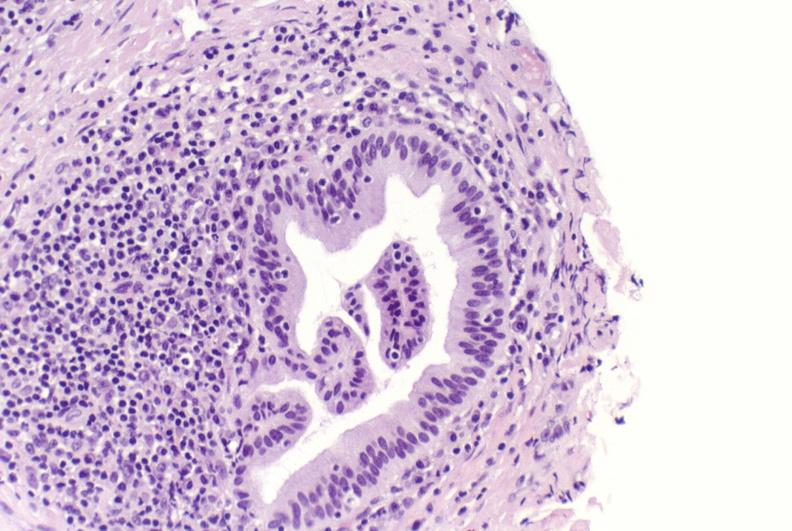what is present?
Answer the question using a single word or phrase. Liver 